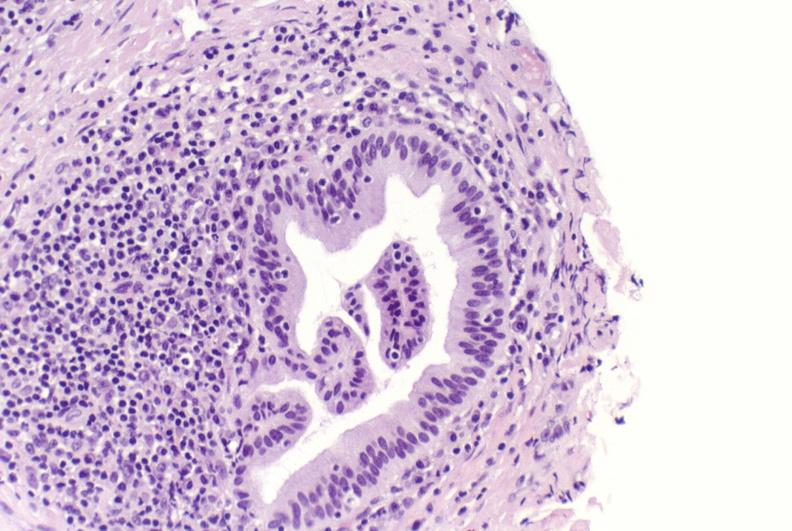what is present?
Answer the question using a single word or phrase. Liver 